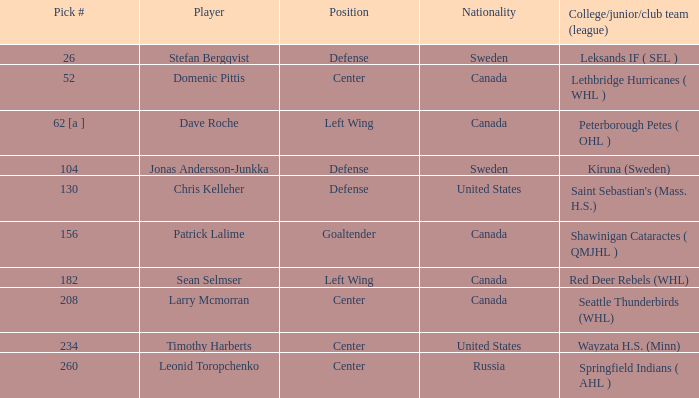What is the nationality of the player whose college/junior/club team (league) is Seattle Thunderbirds (WHL)? Canada. 